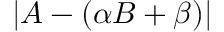<formula> <loc_0><loc_0><loc_500><loc_500>\left | A - \left ( \alpha B + \beta \right ) \right |</formula> 